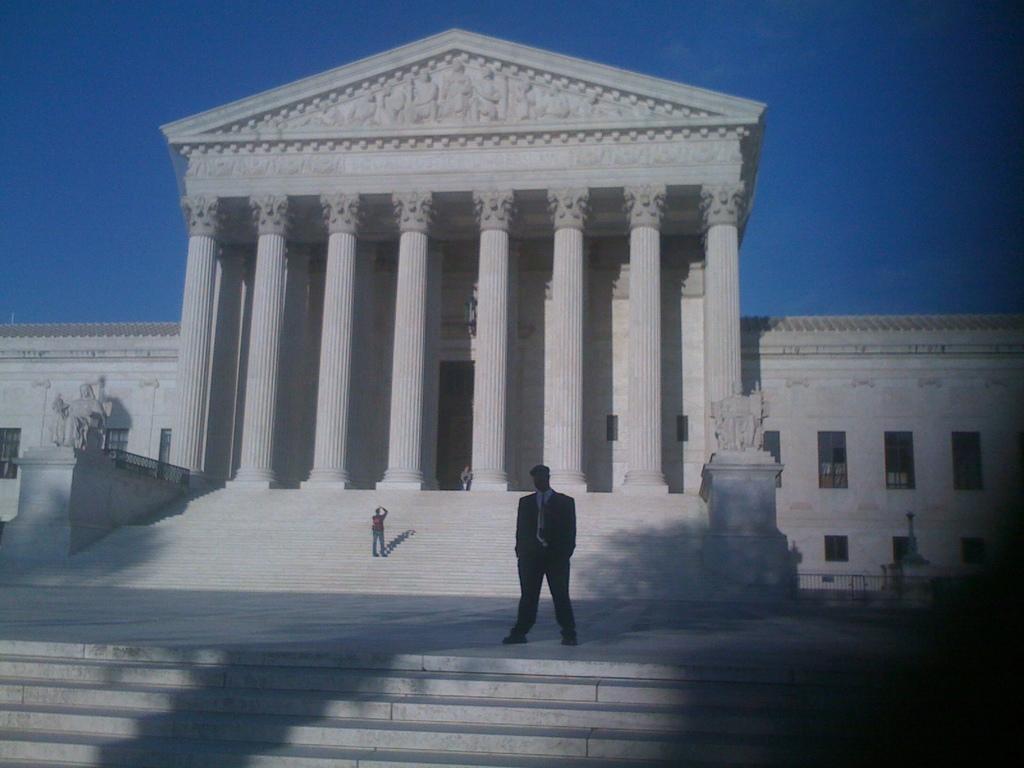Please provide a concise description of this image. In the middle a man is standing, he wore coat, trouser, shirt, tie and this is the monument in white color. At the top it is the sky. 